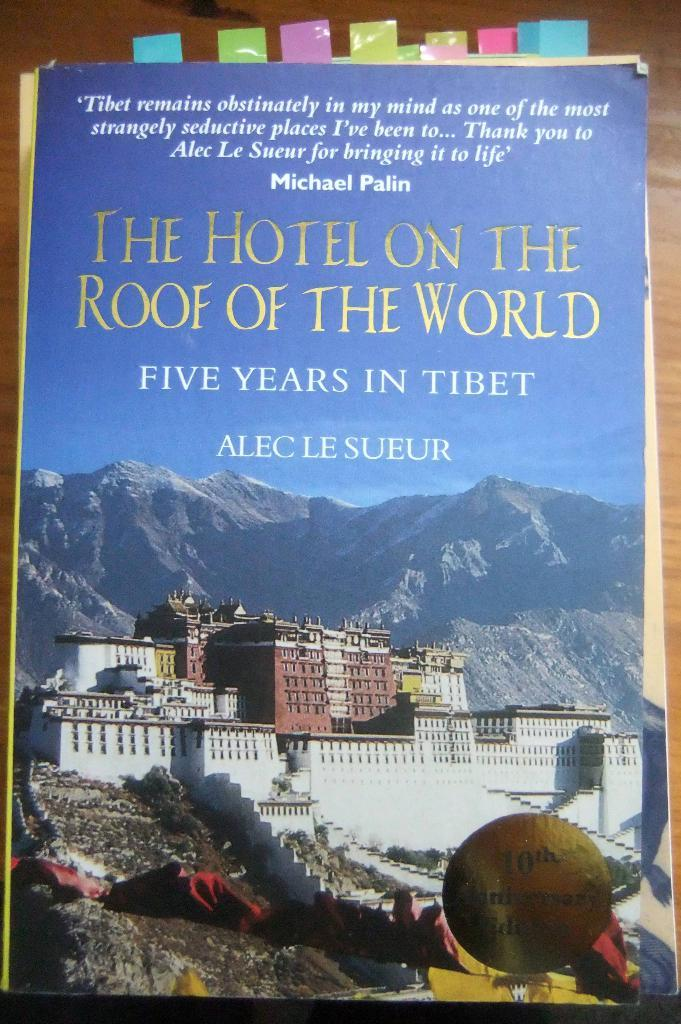Provide a one-sentence caption for the provided image. A book titled, "The Hotel on the Roof of the World" has colored flags at the top. 